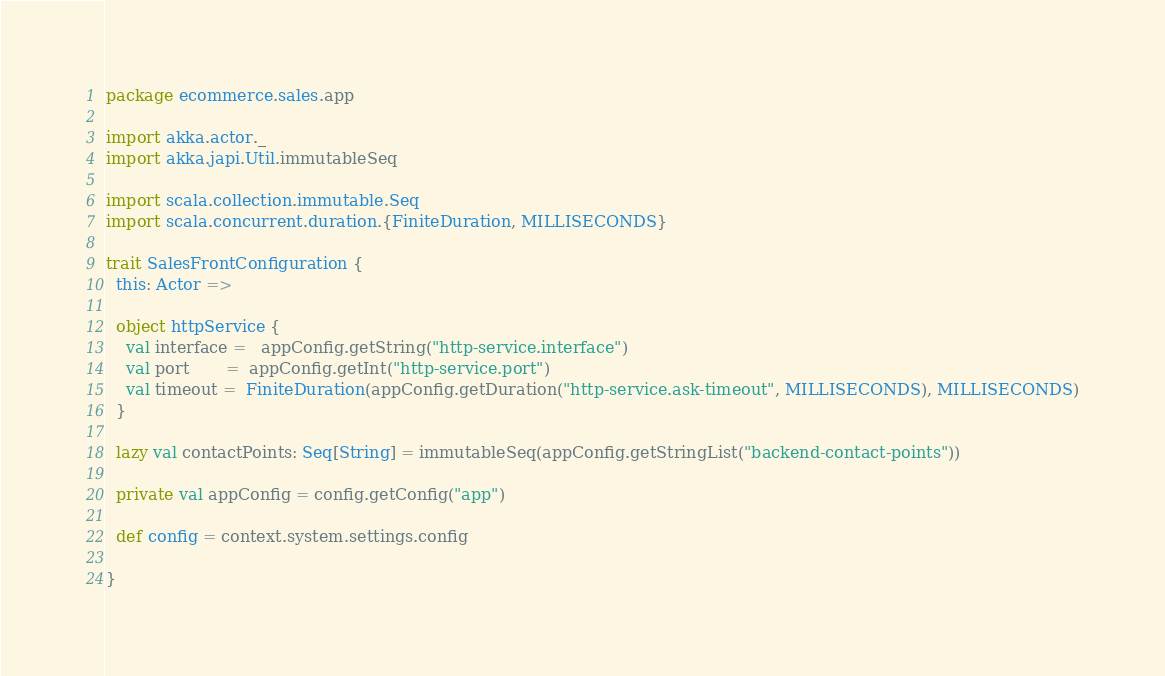<code> <loc_0><loc_0><loc_500><loc_500><_Scala_>package ecommerce.sales.app

import akka.actor._
import akka.japi.Util.immutableSeq

import scala.collection.immutable.Seq
import scala.concurrent.duration.{FiniteDuration, MILLISECONDS}

trait SalesFrontConfiguration {
  this: Actor =>

  object httpService {
    val interface =   appConfig.getString("http-service.interface")
    val port       =  appConfig.getInt("http-service.port")
    val timeout =  FiniteDuration(appConfig.getDuration("http-service.ask-timeout", MILLISECONDS), MILLISECONDS)
  }

  lazy val contactPoints: Seq[String] = immutableSeq(appConfig.getStringList("backend-contact-points"))

  private val appConfig = config.getConfig("app")

  def config = context.system.settings.config

}</code> 